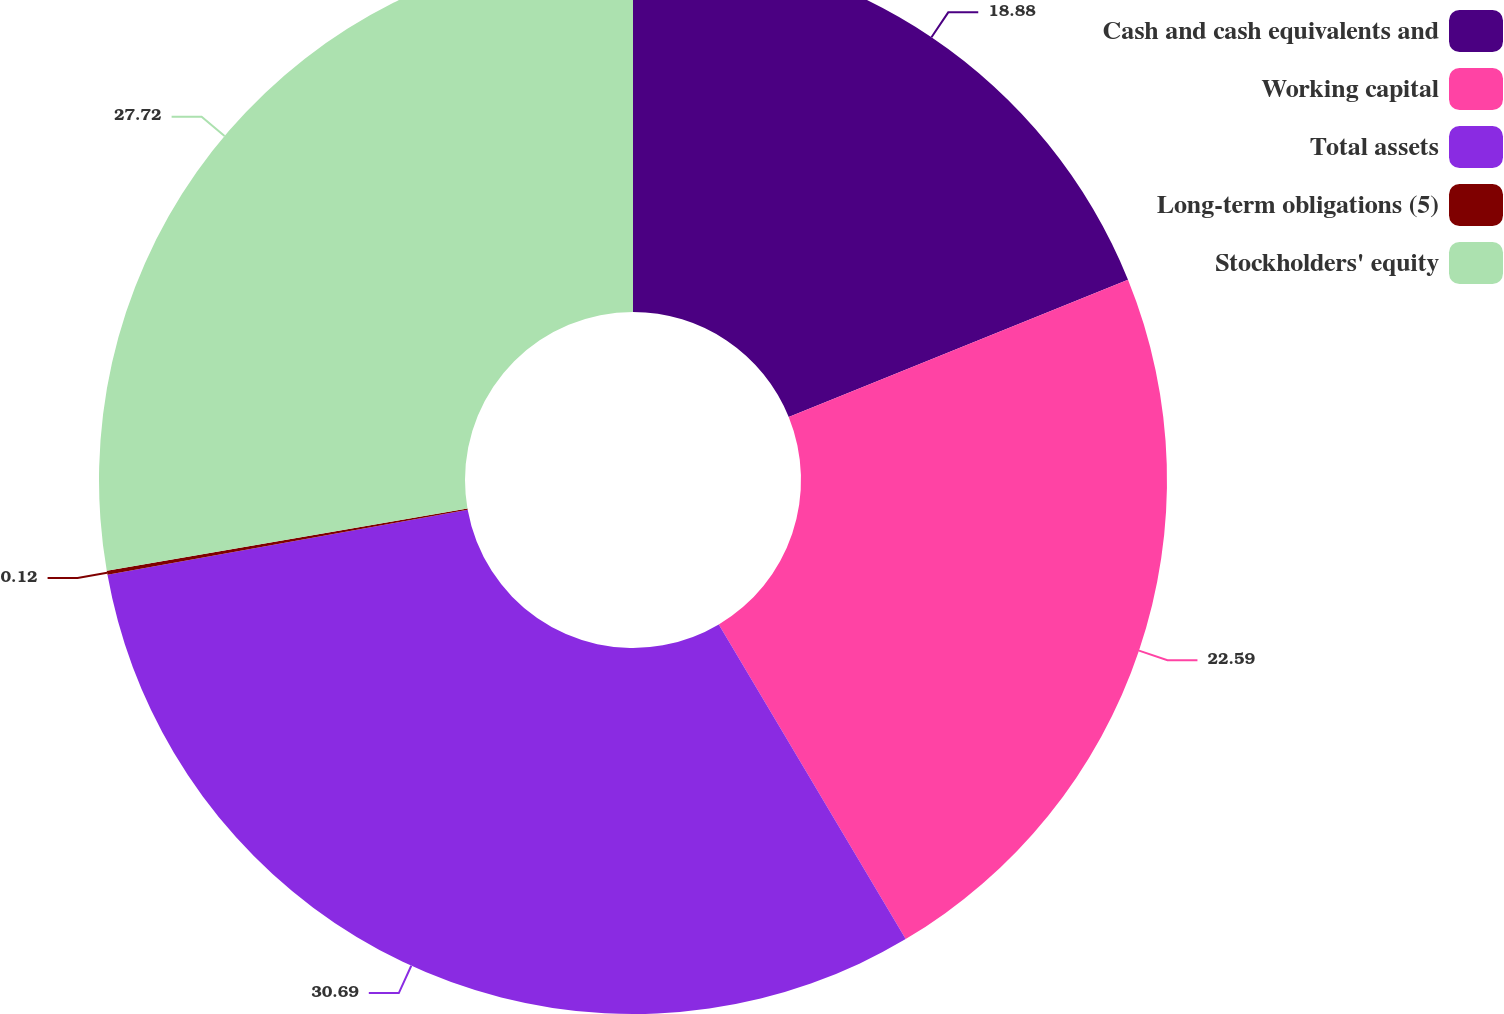Convert chart. <chart><loc_0><loc_0><loc_500><loc_500><pie_chart><fcel>Cash and cash equivalents and<fcel>Working capital<fcel>Total assets<fcel>Long-term obligations (5)<fcel>Stockholders' equity<nl><fcel>18.88%<fcel>22.59%<fcel>30.69%<fcel>0.12%<fcel>27.72%<nl></chart> 